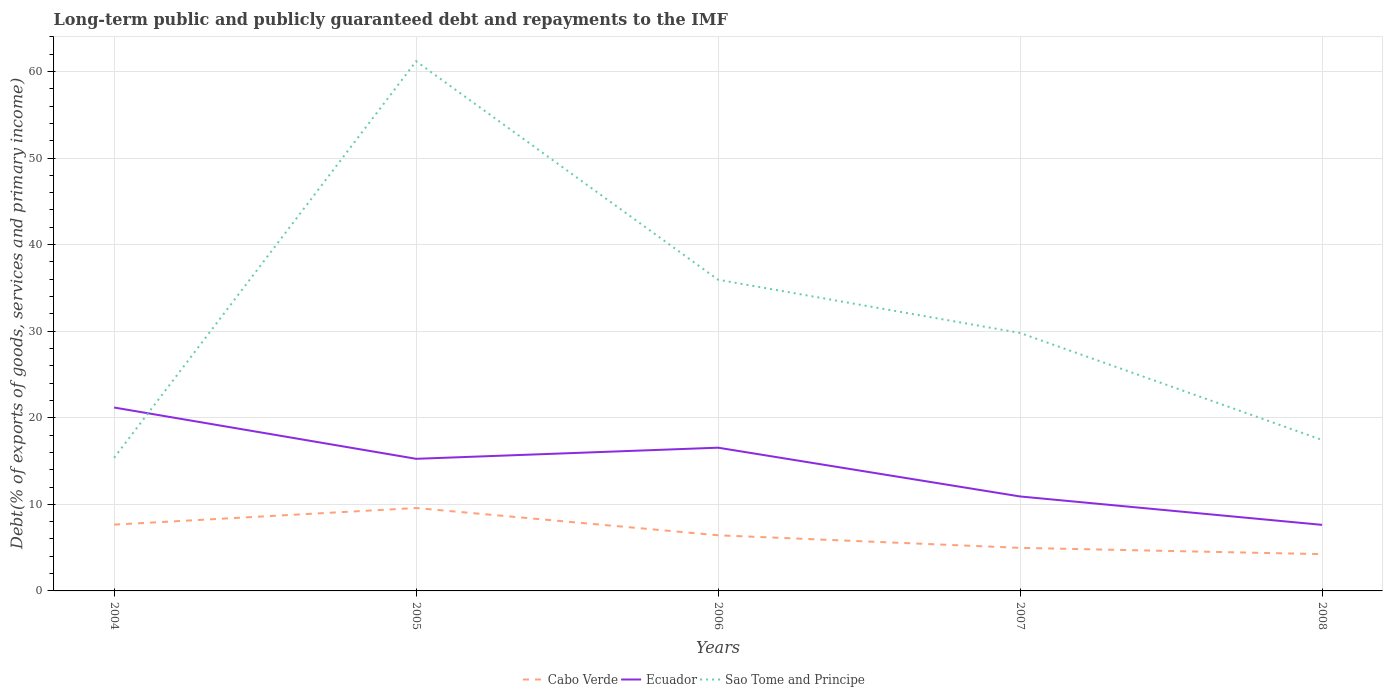How many different coloured lines are there?
Give a very brief answer. 3. Does the line corresponding to Cabo Verde intersect with the line corresponding to Ecuador?
Your response must be concise. No. Across all years, what is the maximum debt and repayments in Sao Tome and Principe?
Offer a very short reply. 15.38. In which year was the debt and repayments in Sao Tome and Principe maximum?
Your answer should be compact. 2004. What is the total debt and repayments in Cabo Verde in the graph?
Your response must be concise. 0.73. What is the difference between the highest and the second highest debt and repayments in Sao Tome and Principe?
Offer a very short reply. 45.81. What is the difference between the highest and the lowest debt and repayments in Cabo Verde?
Your answer should be compact. 2. Are the values on the major ticks of Y-axis written in scientific E-notation?
Keep it short and to the point. No. Does the graph contain grids?
Make the answer very short. Yes. How many legend labels are there?
Offer a terse response. 3. What is the title of the graph?
Your answer should be compact. Long-term public and publicly guaranteed debt and repayments to the IMF. What is the label or title of the X-axis?
Provide a succinct answer. Years. What is the label or title of the Y-axis?
Ensure brevity in your answer.  Debt(% of exports of goods, services and primary income). What is the Debt(% of exports of goods, services and primary income) of Cabo Verde in 2004?
Your answer should be very brief. 7.66. What is the Debt(% of exports of goods, services and primary income) of Ecuador in 2004?
Ensure brevity in your answer.  21.18. What is the Debt(% of exports of goods, services and primary income) of Sao Tome and Principe in 2004?
Keep it short and to the point. 15.38. What is the Debt(% of exports of goods, services and primary income) in Cabo Verde in 2005?
Offer a very short reply. 9.58. What is the Debt(% of exports of goods, services and primary income) of Ecuador in 2005?
Make the answer very short. 15.26. What is the Debt(% of exports of goods, services and primary income) of Sao Tome and Principe in 2005?
Make the answer very short. 61.18. What is the Debt(% of exports of goods, services and primary income) in Cabo Verde in 2006?
Your response must be concise. 6.43. What is the Debt(% of exports of goods, services and primary income) in Ecuador in 2006?
Provide a succinct answer. 16.54. What is the Debt(% of exports of goods, services and primary income) in Sao Tome and Principe in 2006?
Give a very brief answer. 35.94. What is the Debt(% of exports of goods, services and primary income) in Cabo Verde in 2007?
Your answer should be very brief. 4.97. What is the Debt(% of exports of goods, services and primary income) in Ecuador in 2007?
Your answer should be very brief. 10.91. What is the Debt(% of exports of goods, services and primary income) of Sao Tome and Principe in 2007?
Offer a terse response. 29.8. What is the Debt(% of exports of goods, services and primary income) in Cabo Verde in 2008?
Provide a succinct answer. 4.25. What is the Debt(% of exports of goods, services and primary income) in Ecuador in 2008?
Provide a succinct answer. 7.63. What is the Debt(% of exports of goods, services and primary income) in Sao Tome and Principe in 2008?
Make the answer very short. 17.44. Across all years, what is the maximum Debt(% of exports of goods, services and primary income) in Cabo Verde?
Provide a succinct answer. 9.58. Across all years, what is the maximum Debt(% of exports of goods, services and primary income) in Ecuador?
Provide a succinct answer. 21.18. Across all years, what is the maximum Debt(% of exports of goods, services and primary income) in Sao Tome and Principe?
Ensure brevity in your answer.  61.18. Across all years, what is the minimum Debt(% of exports of goods, services and primary income) of Cabo Verde?
Provide a succinct answer. 4.25. Across all years, what is the minimum Debt(% of exports of goods, services and primary income) in Ecuador?
Offer a very short reply. 7.63. Across all years, what is the minimum Debt(% of exports of goods, services and primary income) of Sao Tome and Principe?
Give a very brief answer. 15.38. What is the total Debt(% of exports of goods, services and primary income) in Cabo Verde in the graph?
Your response must be concise. 32.88. What is the total Debt(% of exports of goods, services and primary income) in Ecuador in the graph?
Offer a very short reply. 71.53. What is the total Debt(% of exports of goods, services and primary income) in Sao Tome and Principe in the graph?
Your answer should be very brief. 159.73. What is the difference between the Debt(% of exports of goods, services and primary income) of Cabo Verde in 2004 and that in 2005?
Your response must be concise. -1.92. What is the difference between the Debt(% of exports of goods, services and primary income) of Ecuador in 2004 and that in 2005?
Your answer should be very brief. 5.92. What is the difference between the Debt(% of exports of goods, services and primary income) of Sao Tome and Principe in 2004 and that in 2005?
Provide a short and direct response. -45.81. What is the difference between the Debt(% of exports of goods, services and primary income) in Cabo Verde in 2004 and that in 2006?
Offer a very short reply. 1.23. What is the difference between the Debt(% of exports of goods, services and primary income) of Ecuador in 2004 and that in 2006?
Your answer should be very brief. 4.64. What is the difference between the Debt(% of exports of goods, services and primary income) in Sao Tome and Principe in 2004 and that in 2006?
Offer a very short reply. -20.57. What is the difference between the Debt(% of exports of goods, services and primary income) in Cabo Verde in 2004 and that in 2007?
Provide a succinct answer. 2.68. What is the difference between the Debt(% of exports of goods, services and primary income) of Ecuador in 2004 and that in 2007?
Your answer should be compact. 10.27. What is the difference between the Debt(% of exports of goods, services and primary income) of Sao Tome and Principe in 2004 and that in 2007?
Keep it short and to the point. -14.42. What is the difference between the Debt(% of exports of goods, services and primary income) in Cabo Verde in 2004 and that in 2008?
Provide a short and direct response. 3.41. What is the difference between the Debt(% of exports of goods, services and primary income) in Ecuador in 2004 and that in 2008?
Your answer should be very brief. 13.55. What is the difference between the Debt(% of exports of goods, services and primary income) of Sao Tome and Principe in 2004 and that in 2008?
Offer a very short reply. -2.06. What is the difference between the Debt(% of exports of goods, services and primary income) in Cabo Verde in 2005 and that in 2006?
Give a very brief answer. 3.15. What is the difference between the Debt(% of exports of goods, services and primary income) in Ecuador in 2005 and that in 2006?
Ensure brevity in your answer.  -1.28. What is the difference between the Debt(% of exports of goods, services and primary income) of Sao Tome and Principe in 2005 and that in 2006?
Provide a short and direct response. 25.24. What is the difference between the Debt(% of exports of goods, services and primary income) of Cabo Verde in 2005 and that in 2007?
Your answer should be compact. 4.6. What is the difference between the Debt(% of exports of goods, services and primary income) of Ecuador in 2005 and that in 2007?
Give a very brief answer. 4.35. What is the difference between the Debt(% of exports of goods, services and primary income) of Sao Tome and Principe in 2005 and that in 2007?
Your answer should be compact. 31.39. What is the difference between the Debt(% of exports of goods, services and primary income) of Cabo Verde in 2005 and that in 2008?
Provide a succinct answer. 5.33. What is the difference between the Debt(% of exports of goods, services and primary income) in Ecuador in 2005 and that in 2008?
Keep it short and to the point. 7.63. What is the difference between the Debt(% of exports of goods, services and primary income) in Sao Tome and Principe in 2005 and that in 2008?
Ensure brevity in your answer.  43.74. What is the difference between the Debt(% of exports of goods, services and primary income) in Cabo Verde in 2006 and that in 2007?
Offer a terse response. 1.45. What is the difference between the Debt(% of exports of goods, services and primary income) of Ecuador in 2006 and that in 2007?
Your response must be concise. 5.63. What is the difference between the Debt(% of exports of goods, services and primary income) of Sao Tome and Principe in 2006 and that in 2007?
Keep it short and to the point. 6.15. What is the difference between the Debt(% of exports of goods, services and primary income) in Cabo Verde in 2006 and that in 2008?
Ensure brevity in your answer.  2.18. What is the difference between the Debt(% of exports of goods, services and primary income) of Ecuador in 2006 and that in 2008?
Your answer should be very brief. 8.91. What is the difference between the Debt(% of exports of goods, services and primary income) in Sao Tome and Principe in 2006 and that in 2008?
Make the answer very short. 18.5. What is the difference between the Debt(% of exports of goods, services and primary income) of Cabo Verde in 2007 and that in 2008?
Provide a short and direct response. 0.73. What is the difference between the Debt(% of exports of goods, services and primary income) in Ecuador in 2007 and that in 2008?
Offer a very short reply. 3.28. What is the difference between the Debt(% of exports of goods, services and primary income) of Sao Tome and Principe in 2007 and that in 2008?
Your answer should be very brief. 12.36. What is the difference between the Debt(% of exports of goods, services and primary income) of Cabo Verde in 2004 and the Debt(% of exports of goods, services and primary income) of Ecuador in 2005?
Keep it short and to the point. -7.6. What is the difference between the Debt(% of exports of goods, services and primary income) of Cabo Verde in 2004 and the Debt(% of exports of goods, services and primary income) of Sao Tome and Principe in 2005?
Ensure brevity in your answer.  -53.52. What is the difference between the Debt(% of exports of goods, services and primary income) of Ecuador in 2004 and the Debt(% of exports of goods, services and primary income) of Sao Tome and Principe in 2005?
Offer a very short reply. -40. What is the difference between the Debt(% of exports of goods, services and primary income) of Cabo Verde in 2004 and the Debt(% of exports of goods, services and primary income) of Ecuador in 2006?
Offer a very short reply. -8.89. What is the difference between the Debt(% of exports of goods, services and primary income) in Cabo Verde in 2004 and the Debt(% of exports of goods, services and primary income) in Sao Tome and Principe in 2006?
Offer a terse response. -28.28. What is the difference between the Debt(% of exports of goods, services and primary income) in Ecuador in 2004 and the Debt(% of exports of goods, services and primary income) in Sao Tome and Principe in 2006?
Your answer should be very brief. -14.76. What is the difference between the Debt(% of exports of goods, services and primary income) of Cabo Verde in 2004 and the Debt(% of exports of goods, services and primary income) of Ecuador in 2007?
Give a very brief answer. -3.25. What is the difference between the Debt(% of exports of goods, services and primary income) of Cabo Verde in 2004 and the Debt(% of exports of goods, services and primary income) of Sao Tome and Principe in 2007?
Provide a succinct answer. -22.14. What is the difference between the Debt(% of exports of goods, services and primary income) of Ecuador in 2004 and the Debt(% of exports of goods, services and primary income) of Sao Tome and Principe in 2007?
Provide a short and direct response. -8.61. What is the difference between the Debt(% of exports of goods, services and primary income) in Cabo Verde in 2004 and the Debt(% of exports of goods, services and primary income) in Ecuador in 2008?
Your answer should be compact. 0.03. What is the difference between the Debt(% of exports of goods, services and primary income) of Cabo Verde in 2004 and the Debt(% of exports of goods, services and primary income) of Sao Tome and Principe in 2008?
Give a very brief answer. -9.78. What is the difference between the Debt(% of exports of goods, services and primary income) of Ecuador in 2004 and the Debt(% of exports of goods, services and primary income) of Sao Tome and Principe in 2008?
Your answer should be compact. 3.74. What is the difference between the Debt(% of exports of goods, services and primary income) of Cabo Verde in 2005 and the Debt(% of exports of goods, services and primary income) of Ecuador in 2006?
Your answer should be compact. -6.97. What is the difference between the Debt(% of exports of goods, services and primary income) in Cabo Verde in 2005 and the Debt(% of exports of goods, services and primary income) in Sao Tome and Principe in 2006?
Keep it short and to the point. -26.36. What is the difference between the Debt(% of exports of goods, services and primary income) in Ecuador in 2005 and the Debt(% of exports of goods, services and primary income) in Sao Tome and Principe in 2006?
Offer a terse response. -20.68. What is the difference between the Debt(% of exports of goods, services and primary income) in Cabo Verde in 2005 and the Debt(% of exports of goods, services and primary income) in Ecuador in 2007?
Offer a terse response. -1.33. What is the difference between the Debt(% of exports of goods, services and primary income) in Cabo Verde in 2005 and the Debt(% of exports of goods, services and primary income) in Sao Tome and Principe in 2007?
Provide a short and direct response. -20.22. What is the difference between the Debt(% of exports of goods, services and primary income) in Ecuador in 2005 and the Debt(% of exports of goods, services and primary income) in Sao Tome and Principe in 2007?
Your answer should be compact. -14.54. What is the difference between the Debt(% of exports of goods, services and primary income) in Cabo Verde in 2005 and the Debt(% of exports of goods, services and primary income) in Ecuador in 2008?
Keep it short and to the point. 1.95. What is the difference between the Debt(% of exports of goods, services and primary income) of Cabo Verde in 2005 and the Debt(% of exports of goods, services and primary income) of Sao Tome and Principe in 2008?
Provide a short and direct response. -7.86. What is the difference between the Debt(% of exports of goods, services and primary income) of Ecuador in 2005 and the Debt(% of exports of goods, services and primary income) of Sao Tome and Principe in 2008?
Offer a very short reply. -2.18. What is the difference between the Debt(% of exports of goods, services and primary income) in Cabo Verde in 2006 and the Debt(% of exports of goods, services and primary income) in Ecuador in 2007?
Your answer should be very brief. -4.48. What is the difference between the Debt(% of exports of goods, services and primary income) of Cabo Verde in 2006 and the Debt(% of exports of goods, services and primary income) of Sao Tome and Principe in 2007?
Provide a short and direct response. -23.37. What is the difference between the Debt(% of exports of goods, services and primary income) in Ecuador in 2006 and the Debt(% of exports of goods, services and primary income) in Sao Tome and Principe in 2007?
Keep it short and to the point. -13.25. What is the difference between the Debt(% of exports of goods, services and primary income) in Cabo Verde in 2006 and the Debt(% of exports of goods, services and primary income) in Ecuador in 2008?
Ensure brevity in your answer.  -1.2. What is the difference between the Debt(% of exports of goods, services and primary income) in Cabo Verde in 2006 and the Debt(% of exports of goods, services and primary income) in Sao Tome and Principe in 2008?
Offer a terse response. -11.01. What is the difference between the Debt(% of exports of goods, services and primary income) of Ecuador in 2006 and the Debt(% of exports of goods, services and primary income) of Sao Tome and Principe in 2008?
Your answer should be very brief. -0.9. What is the difference between the Debt(% of exports of goods, services and primary income) of Cabo Verde in 2007 and the Debt(% of exports of goods, services and primary income) of Ecuador in 2008?
Offer a terse response. -2.65. What is the difference between the Debt(% of exports of goods, services and primary income) of Cabo Verde in 2007 and the Debt(% of exports of goods, services and primary income) of Sao Tome and Principe in 2008?
Your response must be concise. -12.47. What is the difference between the Debt(% of exports of goods, services and primary income) of Ecuador in 2007 and the Debt(% of exports of goods, services and primary income) of Sao Tome and Principe in 2008?
Offer a terse response. -6.53. What is the average Debt(% of exports of goods, services and primary income) of Cabo Verde per year?
Offer a terse response. 6.58. What is the average Debt(% of exports of goods, services and primary income) in Ecuador per year?
Offer a terse response. 14.31. What is the average Debt(% of exports of goods, services and primary income) of Sao Tome and Principe per year?
Offer a terse response. 31.95. In the year 2004, what is the difference between the Debt(% of exports of goods, services and primary income) of Cabo Verde and Debt(% of exports of goods, services and primary income) of Ecuador?
Make the answer very short. -13.53. In the year 2004, what is the difference between the Debt(% of exports of goods, services and primary income) of Cabo Verde and Debt(% of exports of goods, services and primary income) of Sao Tome and Principe?
Your response must be concise. -7.72. In the year 2004, what is the difference between the Debt(% of exports of goods, services and primary income) in Ecuador and Debt(% of exports of goods, services and primary income) in Sao Tome and Principe?
Your response must be concise. 5.81. In the year 2005, what is the difference between the Debt(% of exports of goods, services and primary income) of Cabo Verde and Debt(% of exports of goods, services and primary income) of Ecuador?
Ensure brevity in your answer.  -5.68. In the year 2005, what is the difference between the Debt(% of exports of goods, services and primary income) of Cabo Verde and Debt(% of exports of goods, services and primary income) of Sao Tome and Principe?
Provide a short and direct response. -51.61. In the year 2005, what is the difference between the Debt(% of exports of goods, services and primary income) of Ecuador and Debt(% of exports of goods, services and primary income) of Sao Tome and Principe?
Provide a short and direct response. -45.92. In the year 2006, what is the difference between the Debt(% of exports of goods, services and primary income) of Cabo Verde and Debt(% of exports of goods, services and primary income) of Ecuador?
Ensure brevity in your answer.  -10.12. In the year 2006, what is the difference between the Debt(% of exports of goods, services and primary income) in Cabo Verde and Debt(% of exports of goods, services and primary income) in Sao Tome and Principe?
Your response must be concise. -29.51. In the year 2006, what is the difference between the Debt(% of exports of goods, services and primary income) in Ecuador and Debt(% of exports of goods, services and primary income) in Sao Tome and Principe?
Give a very brief answer. -19.4. In the year 2007, what is the difference between the Debt(% of exports of goods, services and primary income) of Cabo Verde and Debt(% of exports of goods, services and primary income) of Ecuador?
Make the answer very short. -5.94. In the year 2007, what is the difference between the Debt(% of exports of goods, services and primary income) in Cabo Verde and Debt(% of exports of goods, services and primary income) in Sao Tome and Principe?
Your answer should be compact. -24.82. In the year 2007, what is the difference between the Debt(% of exports of goods, services and primary income) in Ecuador and Debt(% of exports of goods, services and primary income) in Sao Tome and Principe?
Offer a terse response. -18.88. In the year 2008, what is the difference between the Debt(% of exports of goods, services and primary income) of Cabo Verde and Debt(% of exports of goods, services and primary income) of Ecuador?
Provide a short and direct response. -3.38. In the year 2008, what is the difference between the Debt(% of exports of goods, services and primary income) in Cabo Verde and Debt(% of exports of goods, services and primary income) in Sao Tome and Principe?
Provide a succinct answer. -13.19. In the year 2008, what is the difference between the Debt(% of exports of goods, services and primary income) of Ecuador and Debt(% of exports of goods, services and primary income) of Sao Tome and Principe?
Provide a short and direct response. -9.81. What is the ratio of the Debt(% of exports of goods, services and primary income) of Cabo Verde in 2004 to that in 2005?
Keep it short and to the point. 0.8. What is the ratio of the Debt(% of exports of goods, services and primary income) of Ecuador in 2004 to that in 2005?
Your answer should be compact. 1.39. What is the ratio of the Debt(% of exports of goods, services and primary income) in Sao Tome and Principe in 2004 to that in 2005?
Offer a very short reply. 0.25. What is the ratio of the Debt(% of exports of goods, services and primary income) of Cabo Verde in 2004 to that in 2006?
Make the answer very short. 1.19. What is the ratio of the Debt(% of exports of goods, services and primary income) of Ecuador in 2004 to that in 2006?
Provide a short and direct response. 1.28. What is the ratio of the Debt(% of exports of goods, services and primary income) in Sao Tome and Principe in 2004 to that in 2006?
Make the answer very short. 0.43. What is the ratio of the Debt(% of exports of goods, services and primary income) of Cabo Verde in 2004 to that in 2007?
Offer a very short reply. 1.54. What is the ratio of the Debt(% of exports of goods, services and primary income) in Ecuador in 2004 to that in 2007?
Offer a very short reply. 1.94. What is the ratio of the Debt(% of exports of goods, services and primary income) of Sao Tome and Principe in 2004 to that in 2007?
Offer a terse response. 0.52. What is the ratio of the Debt(% of exports of goods, services and primary income) of Cabo Verde in 2004 to that in 2008?
Your answer should be compact. 1.8. What is the ratio of the Debt(% of exports of goods, services and primary income) of Ecuador in 2004 to that in 2008?
Make the answer very short. 2.78. What is the ratio of the Debt(% of exports of goods, services and primary income) of Sao Tome and Principe in 2004 to that in 2008?
Give a very brief answer. 0.88. What is the ratio of the Debt(% of exports of goods, services and primary income) of Cabo Verde in 2005 to that in 2006?
Ensure brevity in your answer.  1.49. What is the ratio of the Debt(% of exports of goods, services and primary income) of Ecuador in 2005 to that in 2006?
Give a very brief answer. 0.92. What is the ratio of the Debt(% of exports of goods, services and primary income) of Sao Tome and Principe in 2005 to that in 2006?
Provide a short and direct response. 1.7. What is the ratio of the Debt(% of exports of goods, services and primary income) of Cabo Verde in 2005 to that in 2007?
Your response must be concise. 1.92. What is the ratio of the Debt(% of exports of goods, services and primary income) of Ecuador in 2005 to that in 2007?
Your response must be concise. 1.4. What is the ratio of the Debt(% of exports of goods, services and primary income) in Sao Tome and Principe in 2005 to that in 2007?
Your response must be concise. 2.05. What is the ratio of the Debt(% of exports of goods, services and primary income) of Cabo Verde in 2005 to that in 2008?
Your response must be concise. 2.25. What is the ratio of the Debt(% of exports of goods, services and primary income) in Sao Tome and Principe in 2005 to that in 2008?
Ensure brevity in your answer.  3.51. What is the ratio of the Debt(% of exports of goods, services and primary income) of Cabo Verde in 2006 to that in 2007?
Your response must be concise. 1.29. What is the ratio of the Debt(% of exports of goods, services and primary income) of Ecuador in 2006 to that in 2007?
Your response must be concise. 1.52. What is the ratio of the Debt(% of exports of goods, services and primary income) in Sao Tome and Principe in 2006 to that in 2007?
Provide a succinct answer. 1.21. What is the ratio of the Debt(% of exports of goods, services and primary income) of Cabo Verde in 2006 to that in 2008?
Give a very brief answer. 1.51. What is the ratio of the Debt(% of exports of goods, services and primary income) of Ecuador in 2006 to that in 2008?
Provide a short and direct response. 2.17. What is the ratio of the Debt(% of exports of goods, services and primary income) in Sao Tome and Principe in 2006 to that in 2008?
Your response must be concise. 2.06. What is the ratio of the Debt(% of exports of goods, services and primary income) of Cabo Verde in 2007 to that in 2008?
Give a very brief answer. 1.17. What is the ratio of the Debt(% of exports of goods, services and primary income) in Ecuador in 2007 to that in 2008?
Your answer should be very brief. 1.43. What is the ratio of the Debt(% of exports of goods, services and primary income) of Sao Tome and Principe in 2007 to that in 2008?
Offer a terse response. 1.71. What is the difference between the highest and the second highest Debt(% of exports of goods, services and primary income) of Cabo Verde?
Offer a very short reply. 1.92. What is the difference between the highest and the second highest Debt(% of exports of goods, services and primary income) in Ecuador?
Your answer should be very brief. 4.64. What is the difference between the highest and the second highest Debt(% of exports of goods, services and primary income) in Sao Tome and Principe?
Your answer should be compact. 25.24. What is the difference between the highest and the lowest Debt(% of exports of goods, services and primary income) in Cabo Verde?
Your response must be concise. 5.33. What is the difference between the highest and the lowest Debt(% of exports of goods, services and primary income) in Ecuador?
Ensure brevity in your answer.  13.55. What is the difference between the highest and the lowest Debt(% of exports of goods, services and primary income) of Sao Tome and Principe?
Your answer should be compact. 45.81. 